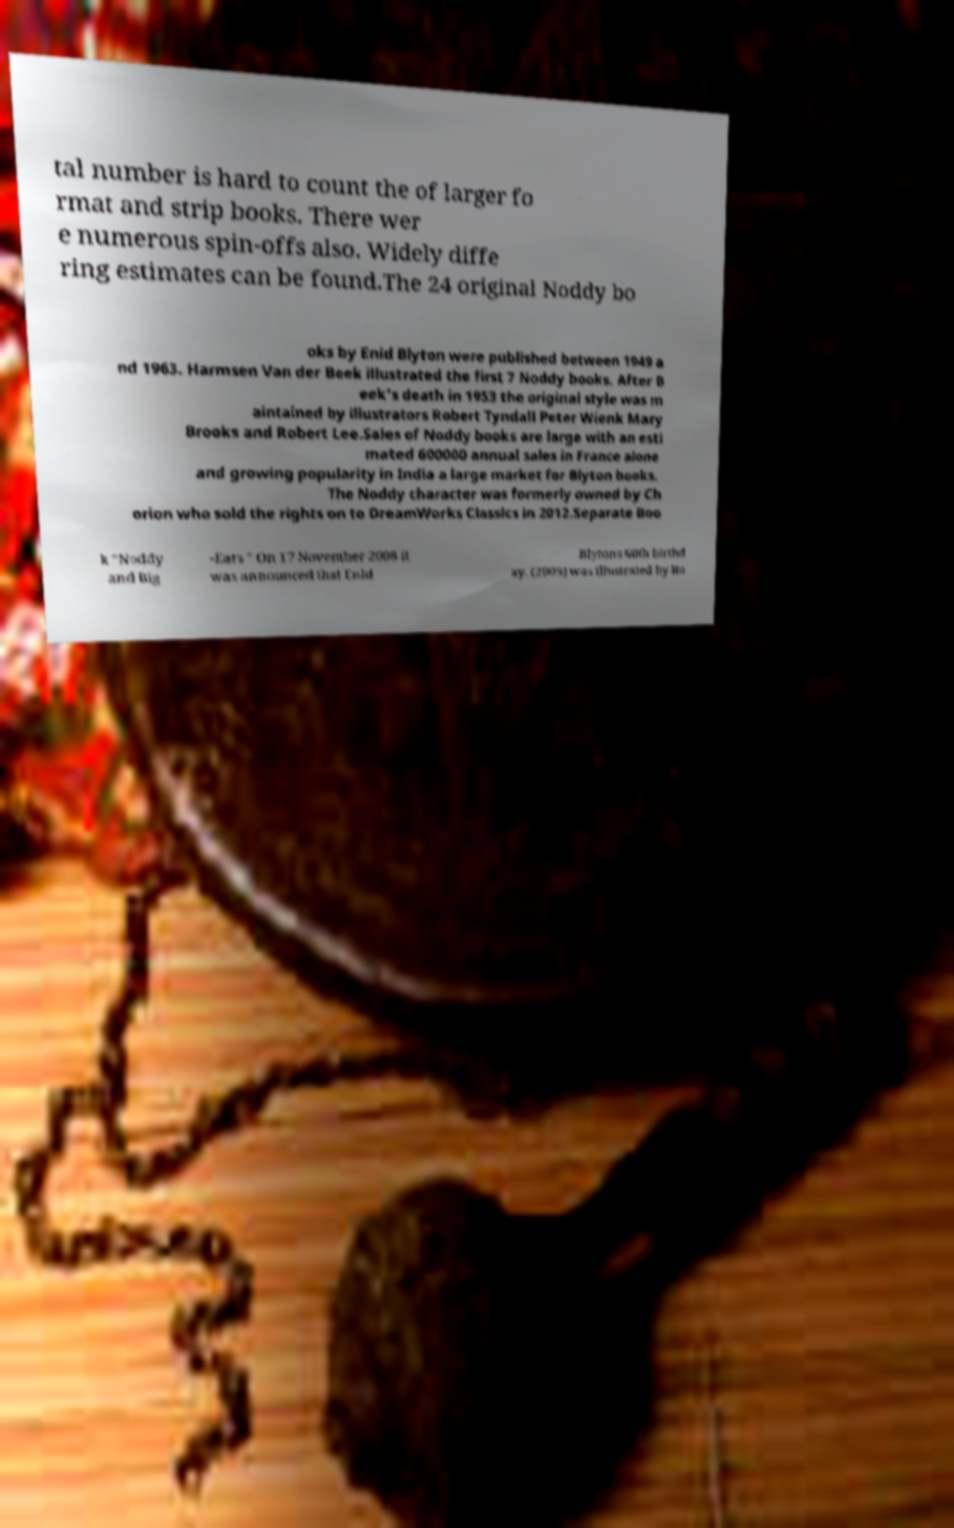Please read and relay the text visible in this image. What does it say? tal number is hard to count the of larger fo rmat and strip books. There wer e numerous spin-offs also. Widely diffe ring estimates can be found.The 24 original Noddy bo oks by Enid Blyton were published between 1949 a nd 1963. Harmsen Van der Beek illustrated the first 7 Noddy books. After B eek's death in 1953 the original style was m aintained by illustrators Robert Tyndall Peter Wienk Mary Brooks and Robert Lee.Sales of Noddy books are large with an esti mated 600000 annual sales in France alone and growing popularity in India a large market for Blyton books. The Noddy character was formerly owned by Ch orion who sold the rights on to DreamWorks Classics in 2012.Separate Boo k "Noddy and Big -Ears " On 17 November 2008 it was announced that Enid Blytons 60th birthd ay. (2009) was illustrated by Ro 